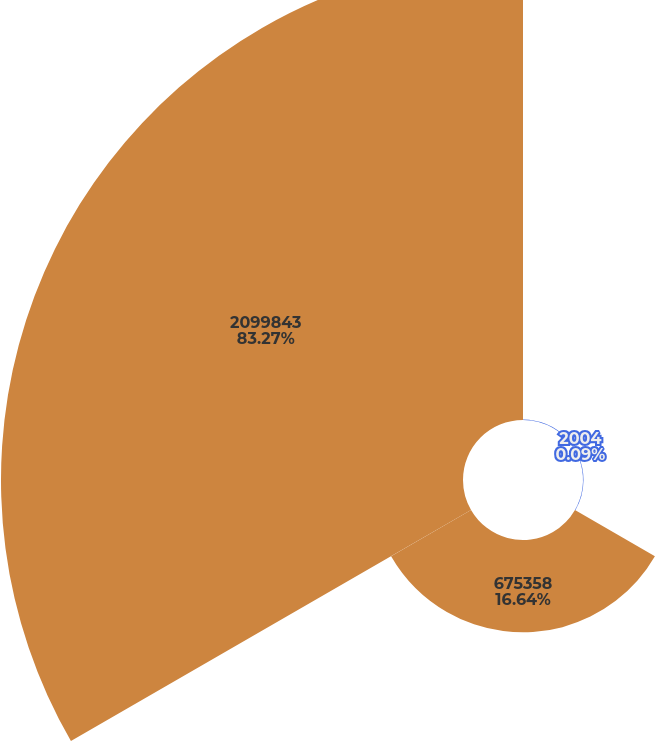Convert chart to OTSL. <chart><loc_0><loc_0><loc_500><loc_500><pie_chart><fcel>2004<fcel>675358<fcel>2099843<nl><fcel>0.09%<fcel>16.64%<fcel>83.27%<nl></chart> 